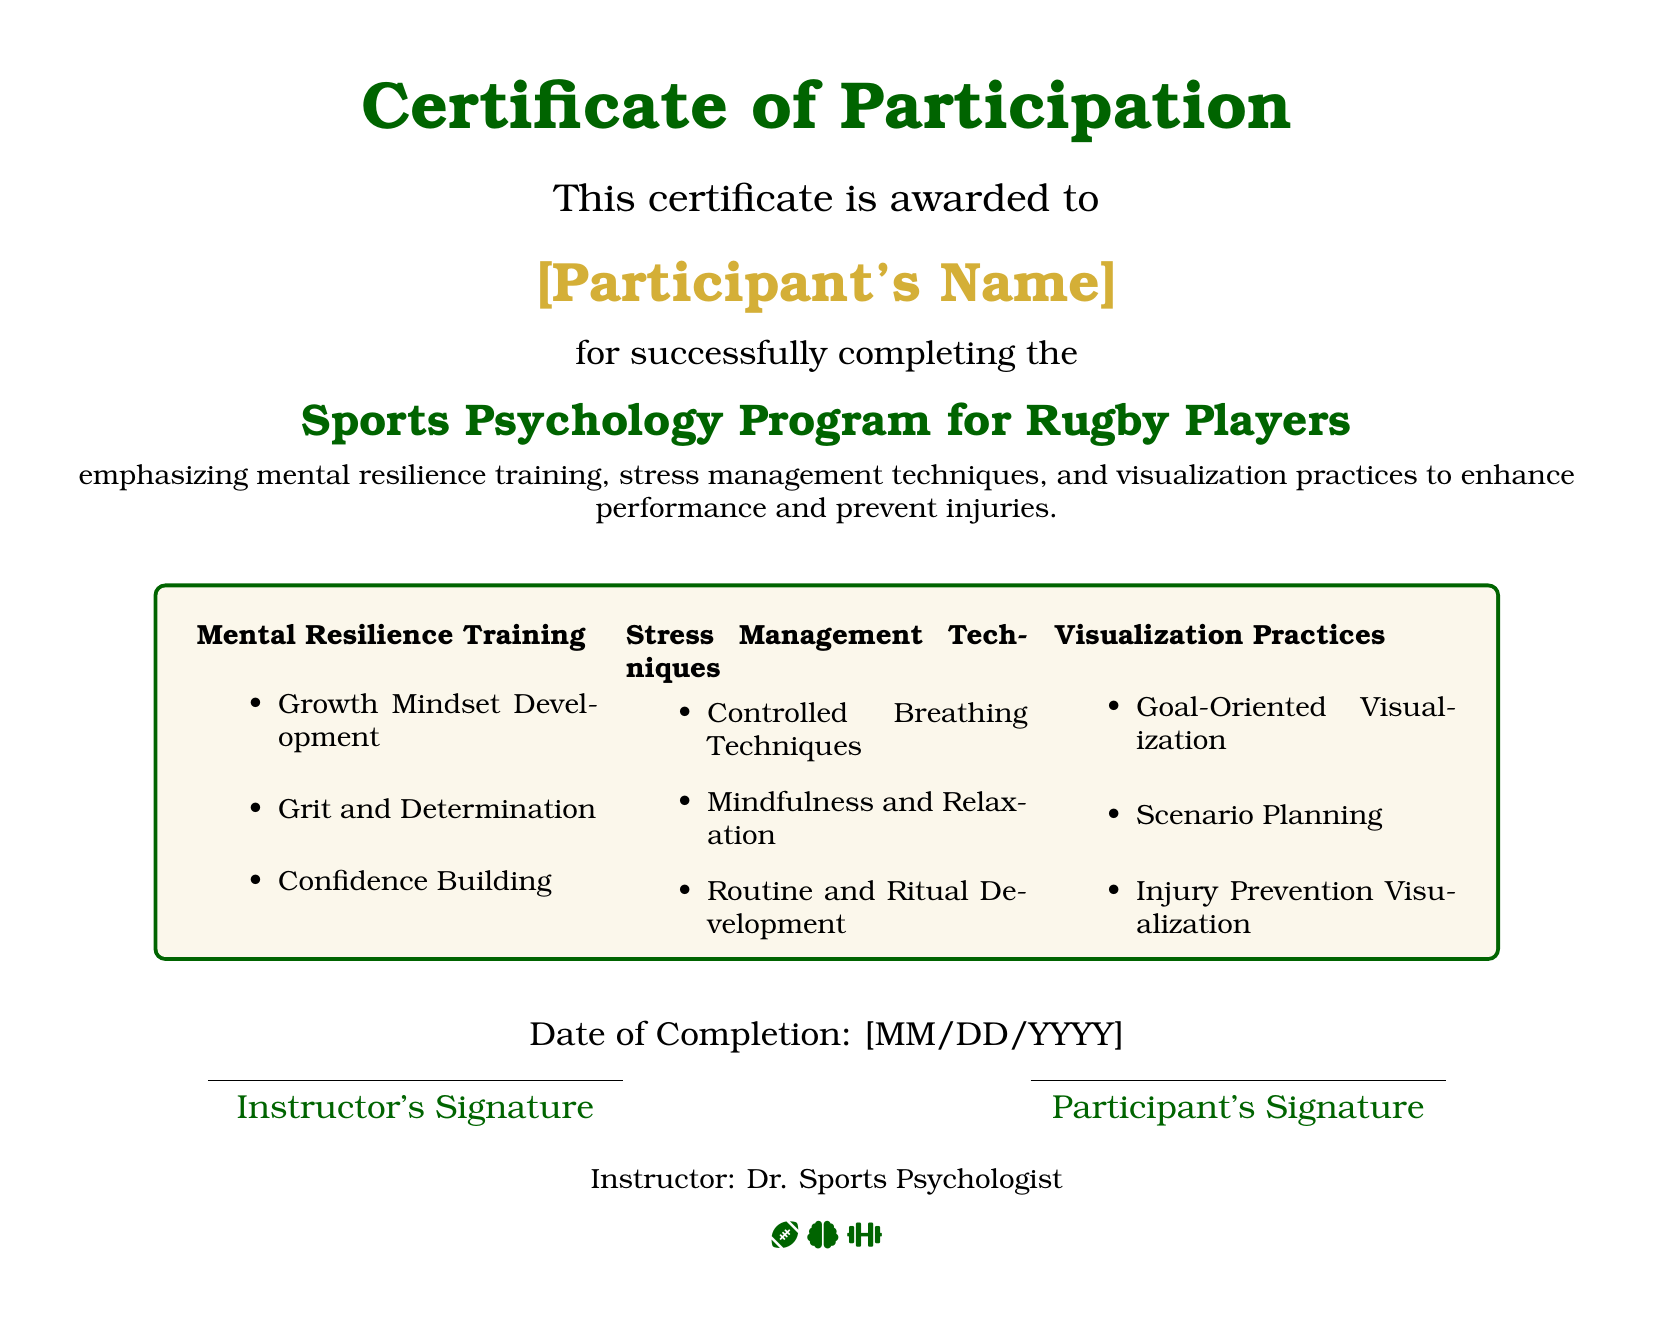What is awarded to the participant? The document certifies completion of a program.
Answer: Certificate of Participation Who is the certificate awarded to? The document specifies the award recipient.
Answer: [Participant's Name] What program did the participant complete? The document mentions the title of the program.
Answer: Sports Psychology Program for Rugby Players What key area emphasizes mental resilience? The document lists specific focus areas, one of which is mental resilience.
Answer: Mental Resilience Training What date is indicated in the document? The document contains a placeholder for the completion date.
Answer: [MM/DD/YYYY] Who is the instructor of the program? The document identifies the name of the instructor.
Answer: Dr. Sports Psychologist What color is used for the headings in the document? The document specifies a color scheme for headings.
Answer: Rugby Green What techniques are mentioned for stress management? The document lists specific techniques under stress management.
Answer: Controlled Breathing Techniques What type of visualization is used for injury prevention? The document highlights a specific practice under visualization.
Answer: Injury Prevention Visualization 